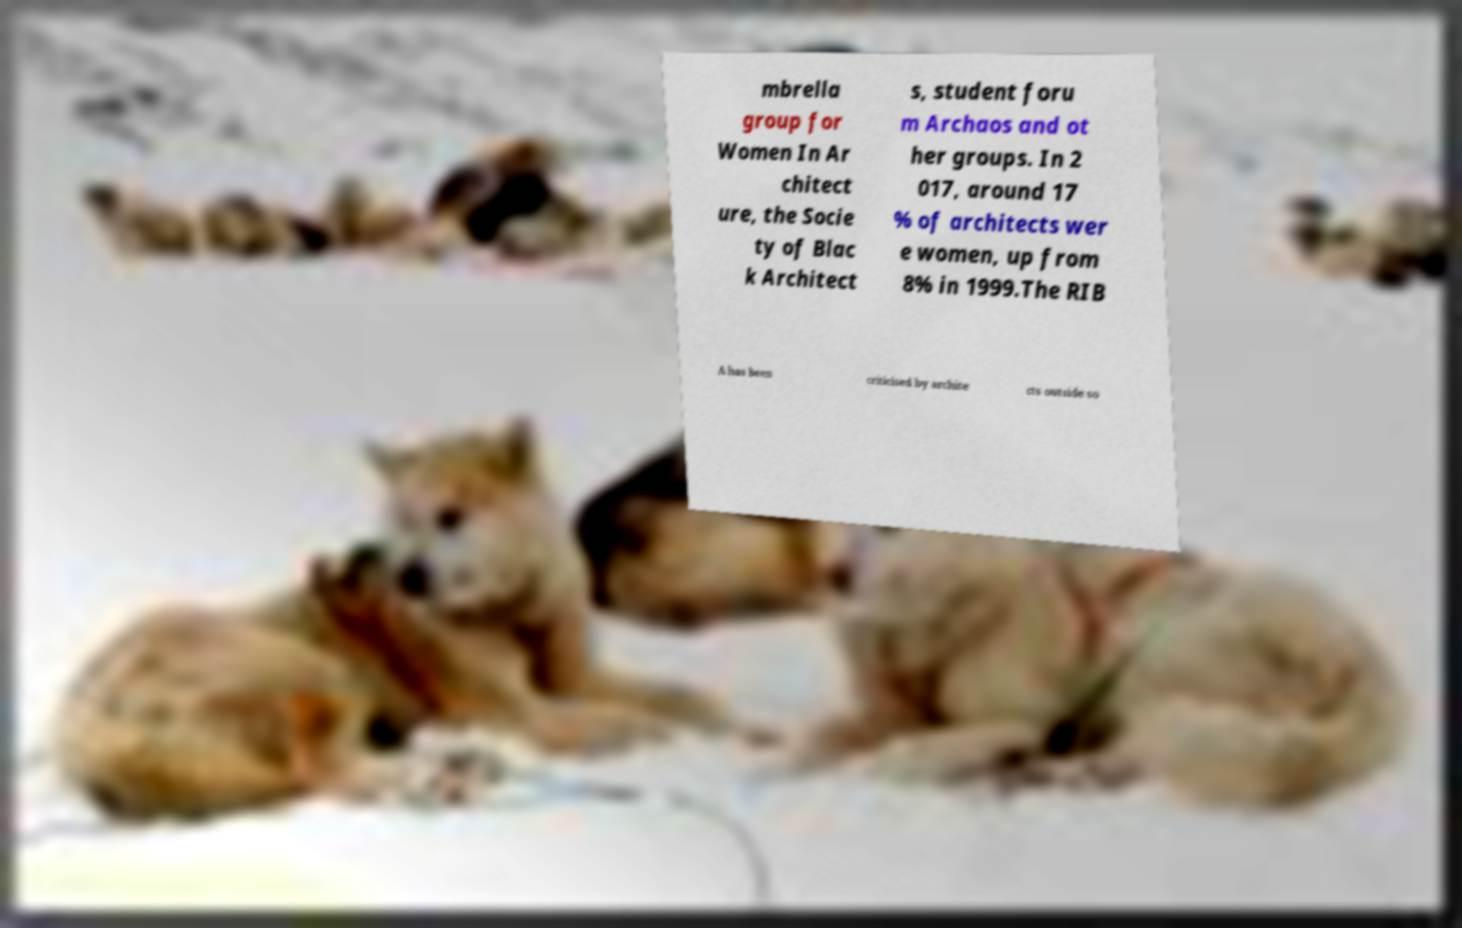What messages or text are displayed in this image? I need them in a readable, typed format. mbrella group for Women In Ar chitect ure, the Socie ty of Blac k Architect s, student foru m Archaos and ot her groups. In 2 017, around 17 % of architects wer e women, up from 8% in 1999.The RIB A has been criticised by archite cts outside so 